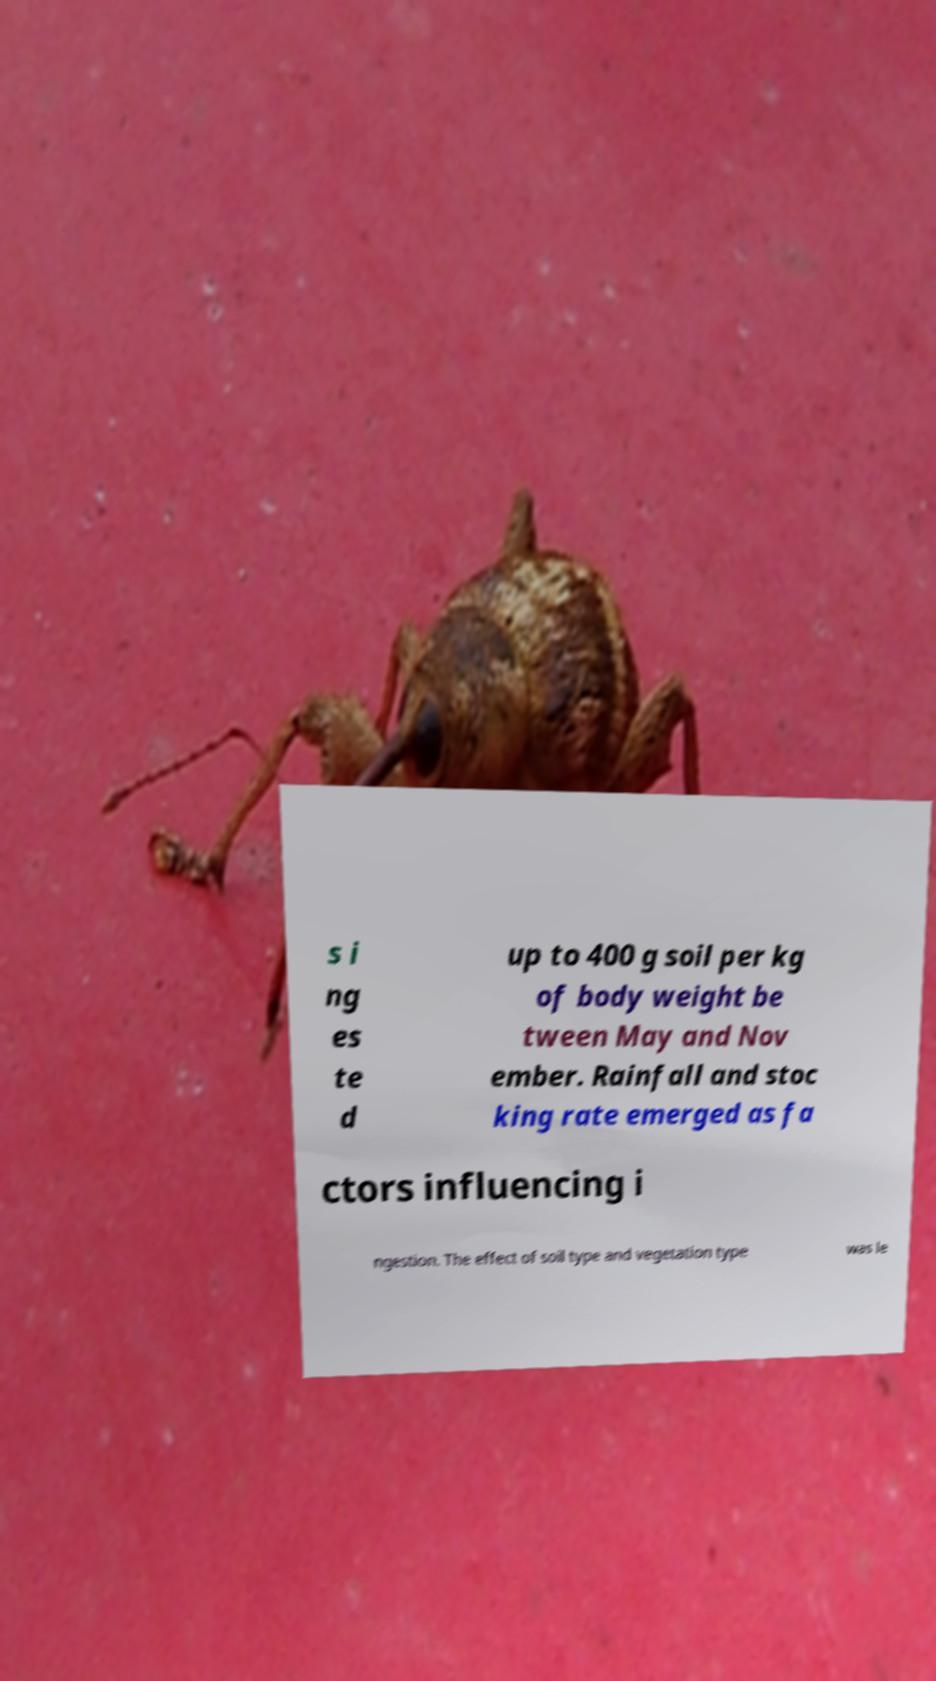Could you assist in decoding the text presented in this image and type it out clearly? s i ng es te d up to 400 g soil per kg of body weight be tween May and Nov ember. Rainfall and stoc king rate emerged as fa ctors influencing i ngestion. The effect of soil type and vegetation type was le 